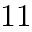Convert formula to latex. <formula><loc_0><loc_0><loc_500><loc_500>1 1</formula> 